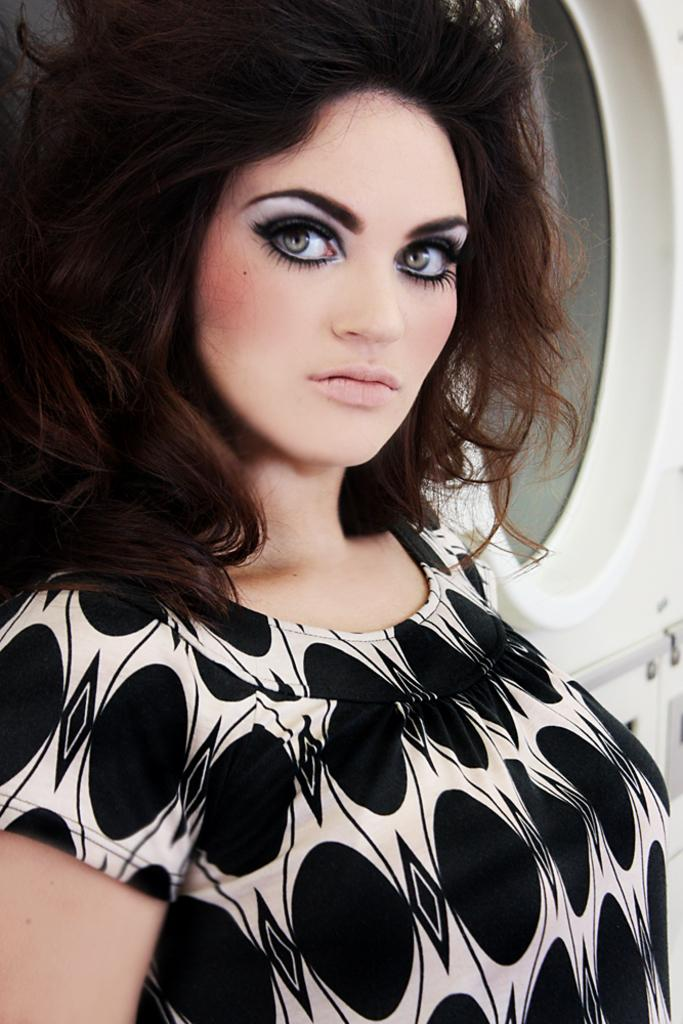What is the main subject in the foreground area of the image? There is a lady in the foreground area of the image. What can be seen in the background of the image? There is a window visible in the background of the image. What type of butter is being used by the lady in the image? There is no butter present in the image, and the lady's actions are not described. Where is the soap located in the image? There is no soap present in the image. 